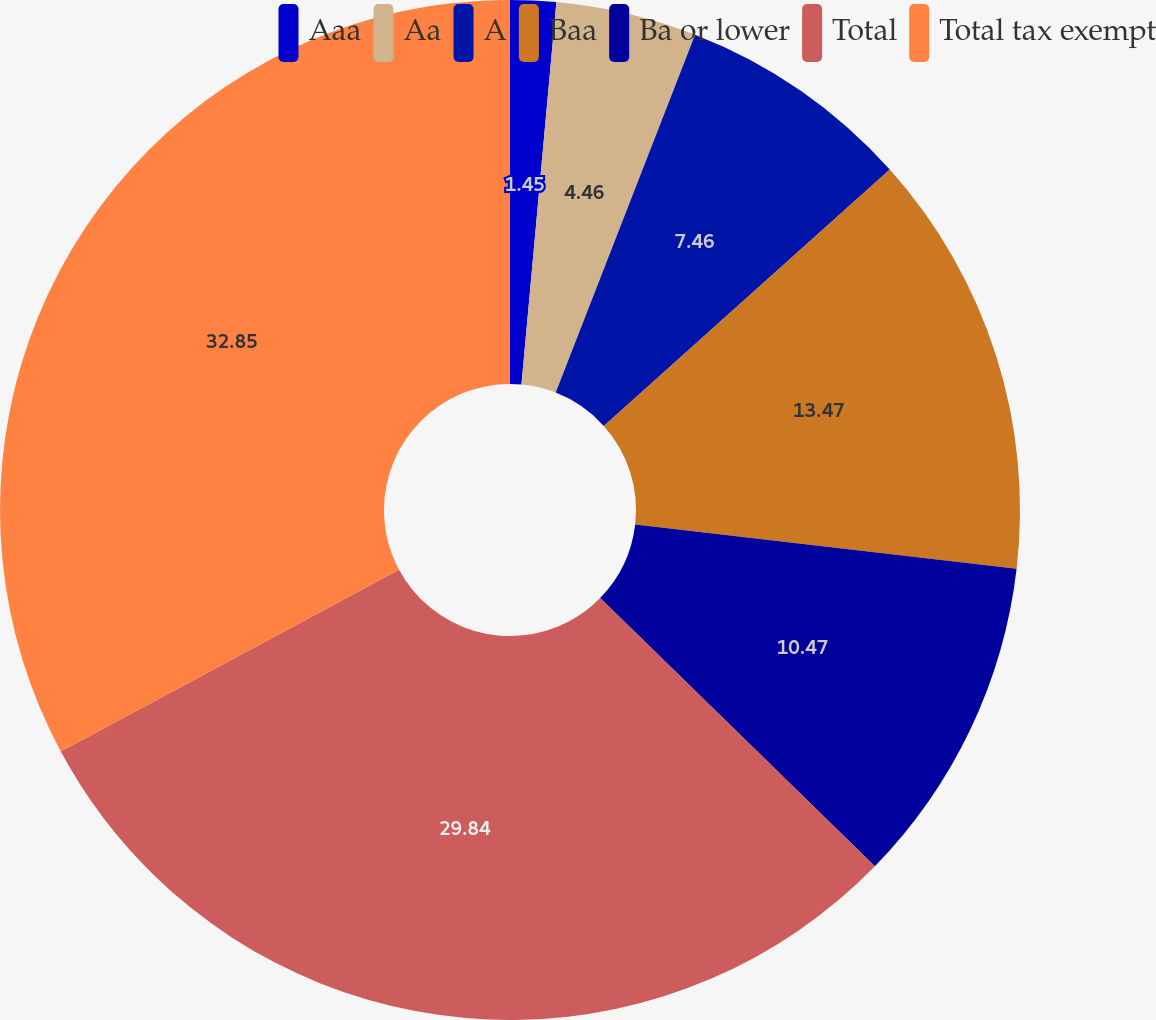Convert chart. <chart><loc_0><loc_0><loc_500><loc_500><pie_chart><fcel>Aaa<fcel>Aa<fcel>A<fcel>Baa<fcel>Ba or lower<fcel>Total<fcel>Total tax exempt<nl><fcel>1.45%<fcel>4.46%<fcel>7.46%<fcel>13.47%<fcel>10.47%<fcel>29.84%<fcel>32.85%<nl></chart> 